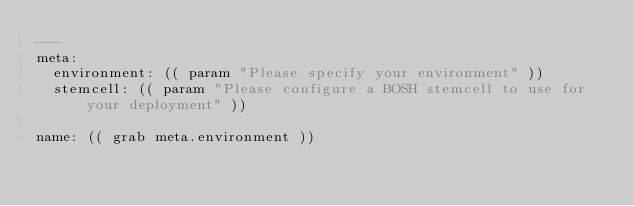Convert code to text. <code><loc_0><loc_0><loc_500><loc_500><_YAML_>---
meta:
  environment: (( param "Please specify your environment" ))
  stemcell: (( param "Please configure a BOSH stemcell to use for your deployment" ))

name: (( grab meta.environment ))
</code> 